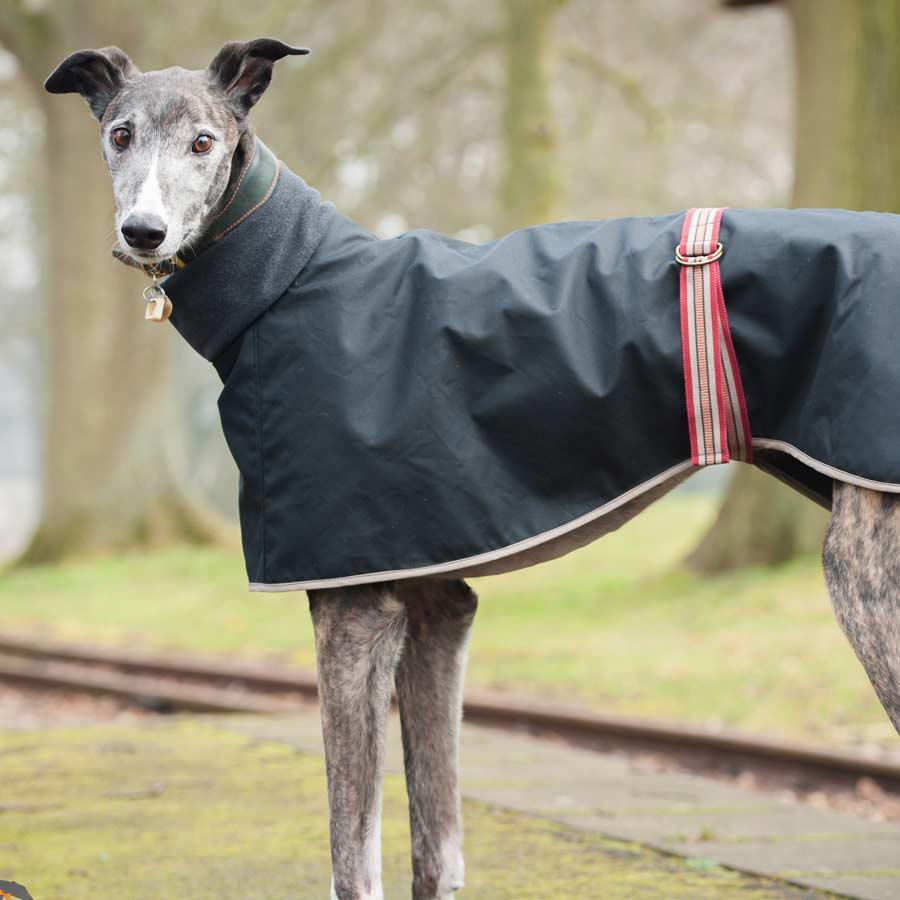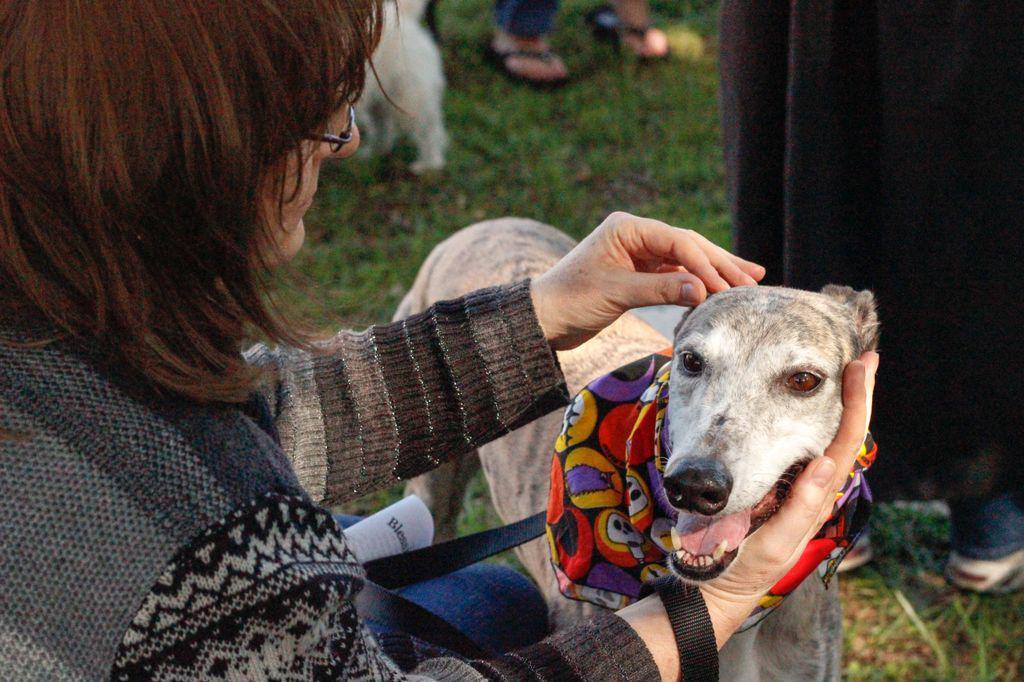The first image is the image on the left, the second image is the image on the right. Analyze the images presented: Is the assertion "An image shows a human hand touching the head of a hound wearing a bandana." valid? Answer yes or no. Yes. The first image is the image on the left, the second image is the image on the right. Analyze the images presented: Is the assertion "A person is with at least one dog in the grass in one of the pictures." valid? Answer yes or no. Yes. 